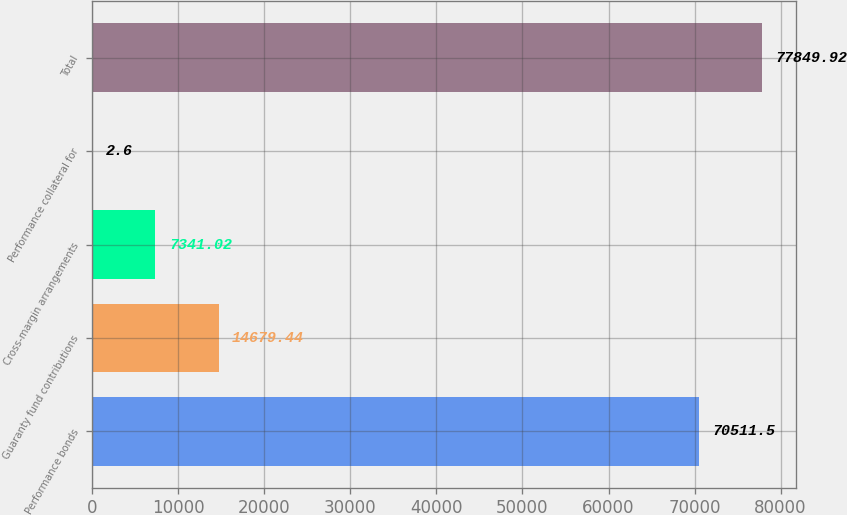Convert chart. <chart><loc_0><loc_0><loc_500><loc_500><bar_chart><fcel>Performance bonds<fcel>Guaranty fund contributions<fcel>Cross-margin arrangements<fcel>Performance collateral for<fcel>Total<nl><fcel>70511.5<fcel>14679.4<fcel>7341.02<fcel>2.6<fcel>77849.9<nl></chart> 